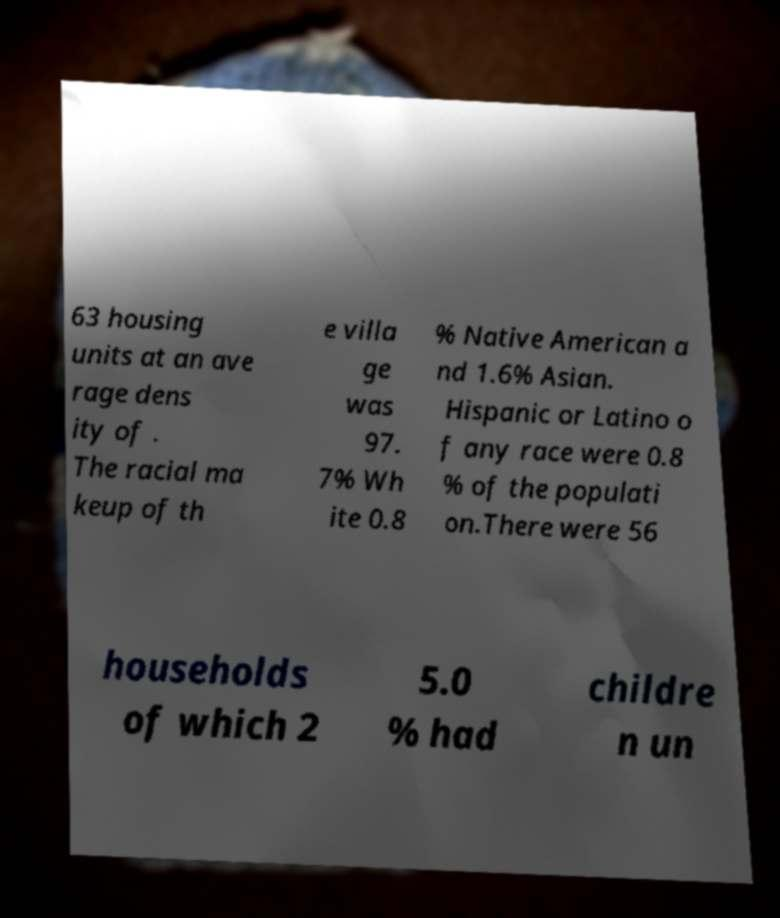Can you read and provide the text displayed in the image?This photo seems to have some interesting text. Can you extract and type it out for me? 63 housing units at an ave rage dens ity of . The racial ma keup of th e villa ge was 97. 7% Wh ite 0.8 % Native American a nd 1.6% Asian. Hispanic or Latino o f any race were 0.8 % of the populati on.There were 56 households of which 2 5.0 % had childre n un 